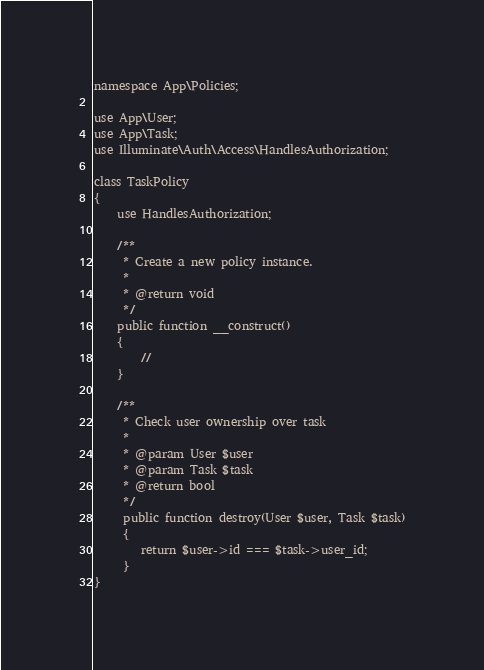Convert code to text. <code><loc_0><loc_0><loc_500><loc_500><_PHP_>namespace App\Policies;

use App\User;
use App\Task;
use Illuminate\Auth\Access\HandlesAuthorization;

class TaskPolicy
{
    use HandlesAuthorization;

    /**
     * Create a new policy instance.
     *
     * @return void
     */
    public function __construct()
    {
        //
    }
    
    /**
     * Check user ownership over task
     *
     * @param User $user
     * @param Task $task
     * @return bool
     */
     public function destroy(User $user, Task $task)
     {
        return $user->id === $task->user_id;
     }
}
</code> 